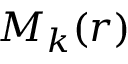<formula> <loc_0><loc_0><loc_500><loc_500>M _ { k } ( r )</formula> 